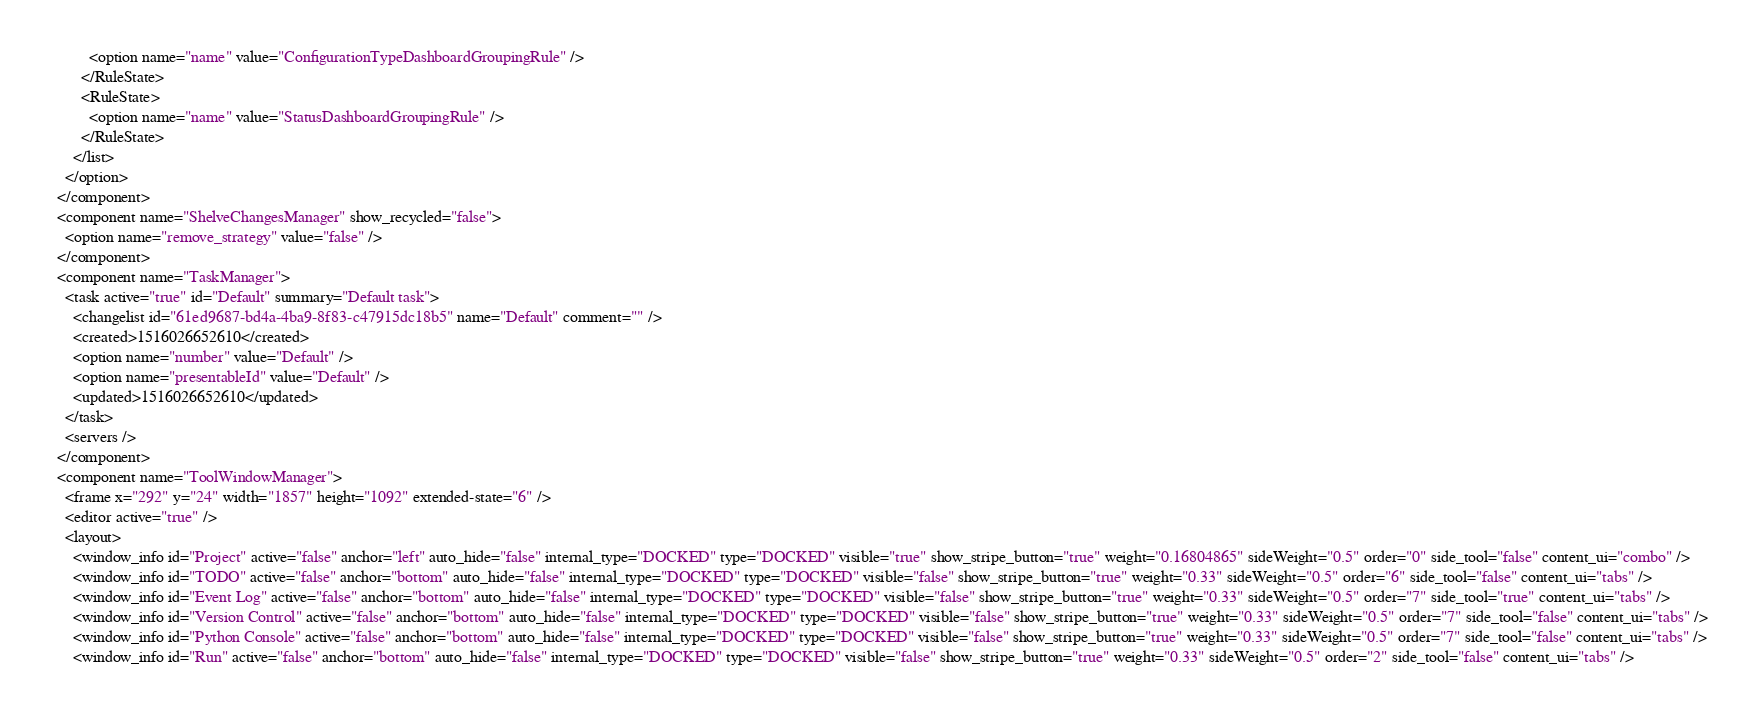Convert code to text. <code><loc_0><loc_0><loc_500><loc_500><_XML_>          <option name="name" value="ConfigurationTypeDashboardGroupingRule" />
        </RuleState>
        <RuleState>
          <option name="name" value="StatusDashboardGroupingRule" />
        </RuleState>
      </list>
    </option>
  </component>
  <component name="ShelveChangesManager" show_recycled="false">
    <option name="remove_strategy" value="false" />
  </component>
  <component name="TaskManager">
    <task active="true" id="Default" summary="Default task">
      <changelist id="61ed9687-bd4a-4ba9-8f83-c47915dc18b5" name="Default" comment="" />
      <created>1516026652610</created>
      <option name="number" value="Default" />
      <option name="presentableId" value="Default" />
      <updated>1516026652610</updated>
    </task>
    <servers />
  </component>
  <component name="ToolWindowManager">
    <frame x="292" y="24" width="1857" height="1092" extended-state="6" />
    <editor active="true" />
    <layout>
      <window_info id="Project" active="false" anchor="left" auto_hide="false" internal_type="DOCKED" type="DOCKED" visible="true" show_stripe_button="true" weight="0.16804865" sideWeight="0.5" order="0" side_tool="false" content_ui="combo" />
      <window_info id="TODO" active="false" anchor="bottom" auto_hide="false" internal_type="DOCKED" type="DOCKED" visible="false" show_stripe_button="true" weight="0.33" sideWeight="0.5" order="6" side_tool="false" content_ui="tabs" />
      <window_info id="Event Log" active="false" anchor="bottom" auto_hide="false" internal_type="DOCKED" type="DOCKED" visible="false" show_stripe_button="true" weight="0.33" sideWeight="0.5" order="7" side_tool="true" content_ui="tabs" />
      <window_info id="Version Control" active="false" anchor="bottom" auto_hide="false" internal_type="DOCKED" type="DOCKED" visible="false" show_stripe_button="true" weight="0.33" sideWeight="0.5" order="7" side_tool="false" content_ui="tabs" />
      <window_info id="Python Console" active="false" anchor="bottom" auto_hide="false" internal_type="DOCKED" type="DOCKED" visible="false" show_stripe_button="true" weight="0.33" sideWeight="0.5" order="7" side_tool="false" content_ui="tabs" />
      <window_info id="Run" active="false" anchor="bottom" auto_hide="false" internal_type="DOCKED" type="DOCKED" visible="false" show_stripe_button="true" weight="0.33" sideWeight="0.5" order="2" side_tool="false" content_ui="tabs" /></code> 